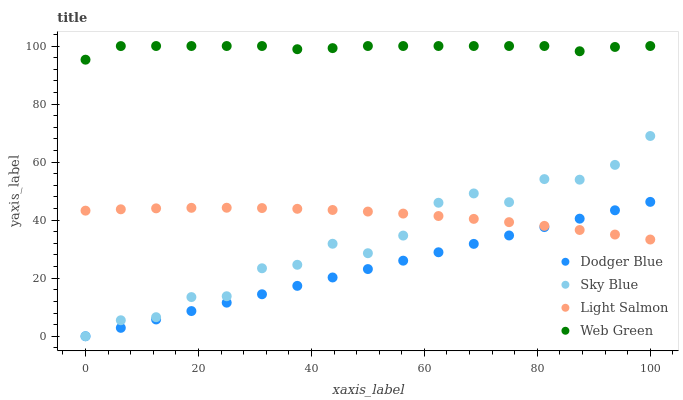Does Dodger Blue have the minimum area under the curve?
Answer yes or no. Yes. Does Web Green have the maximum area under the curve?
Answer yes or no. Yes. Does Light Salmon have the minimum area under the curve?
Answer yes or no. No. Does Light Salmon have the maximum area under the curve?
Answer yes or no. No. Is Dodger Blue the smoothest?
Answer yes or no. Yes. Is Sky Blue the roughest?
Answer yes or no. Yes. Is Light Salmon the smoothest?
Answer yes or no. No. Is Light Salmon the roughest?
Answer yes or no. No. Does Sky Blue have the lowest value?
Answer yes or no. Yes. Does Light Salmon have the lowest value?
Answer yes or no. No. Does Web Green have the highest value?
Answer yes or no. Yes. Does Dodger Blue have the highest value?
Answer yes or no. No. Is Sky Blue less than Web Green?
Answer yes or no. Yes. Is Web Green greater than Sky Blue?
Answer yes or no. Yes. Does Dodger Blue intersect Light Salmon?
Answer yes or no. Yes. Is Dodger Blue less than Light Salmon?
Answer yes or no. No. Is Dodger Blue greater than Light Salmon?
Answer yes or no. No. Does Sky Blue intersect Web Green?
Answer yes or no. No. 